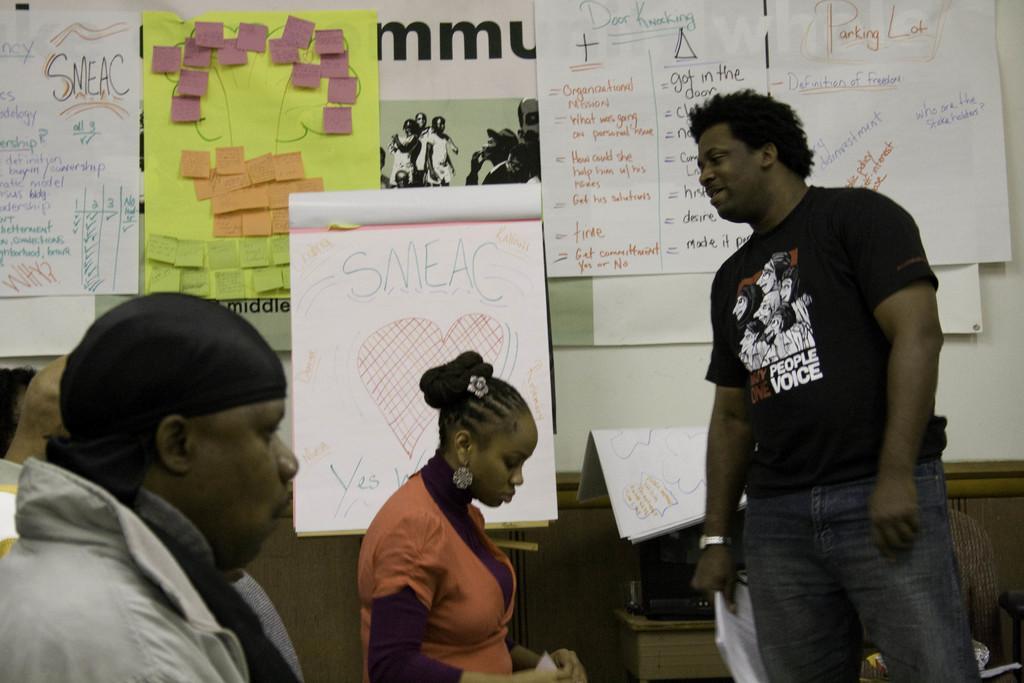Can you describe this image briefly? In this picture there is a man who is wearing black t-shirt and jeans. He is holding a paper. At the bottom there is a woman who is wearing orange dress. On the left there is a man who is wearing black cap. In the background we can see posters, papers and photo frame attached on the wall. In the center there is a board. 